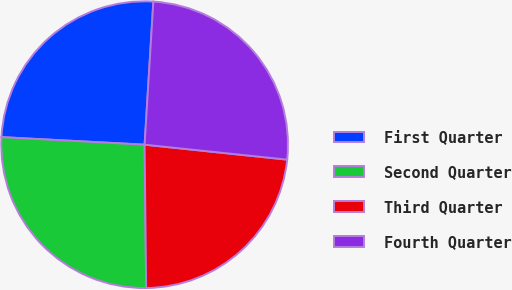<chart> <loc_0><loc_0><loc_500><loc_500><pie_chart><fcel>First Quarter<fcel>Second Quarter<fcel>Third Quarter<fcel>Fourth Quarter<nl><fcel>25.13%<fcel>26.01%<fcel>23.16%<fcel>25.69%<nl></chart> 